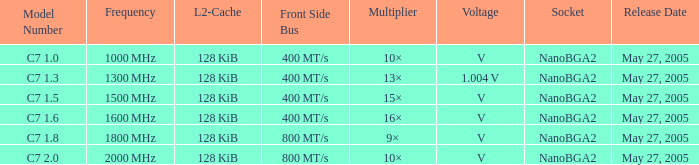What is the Front Side Bus for Model Number c7 1.5? 400 MT/s. 